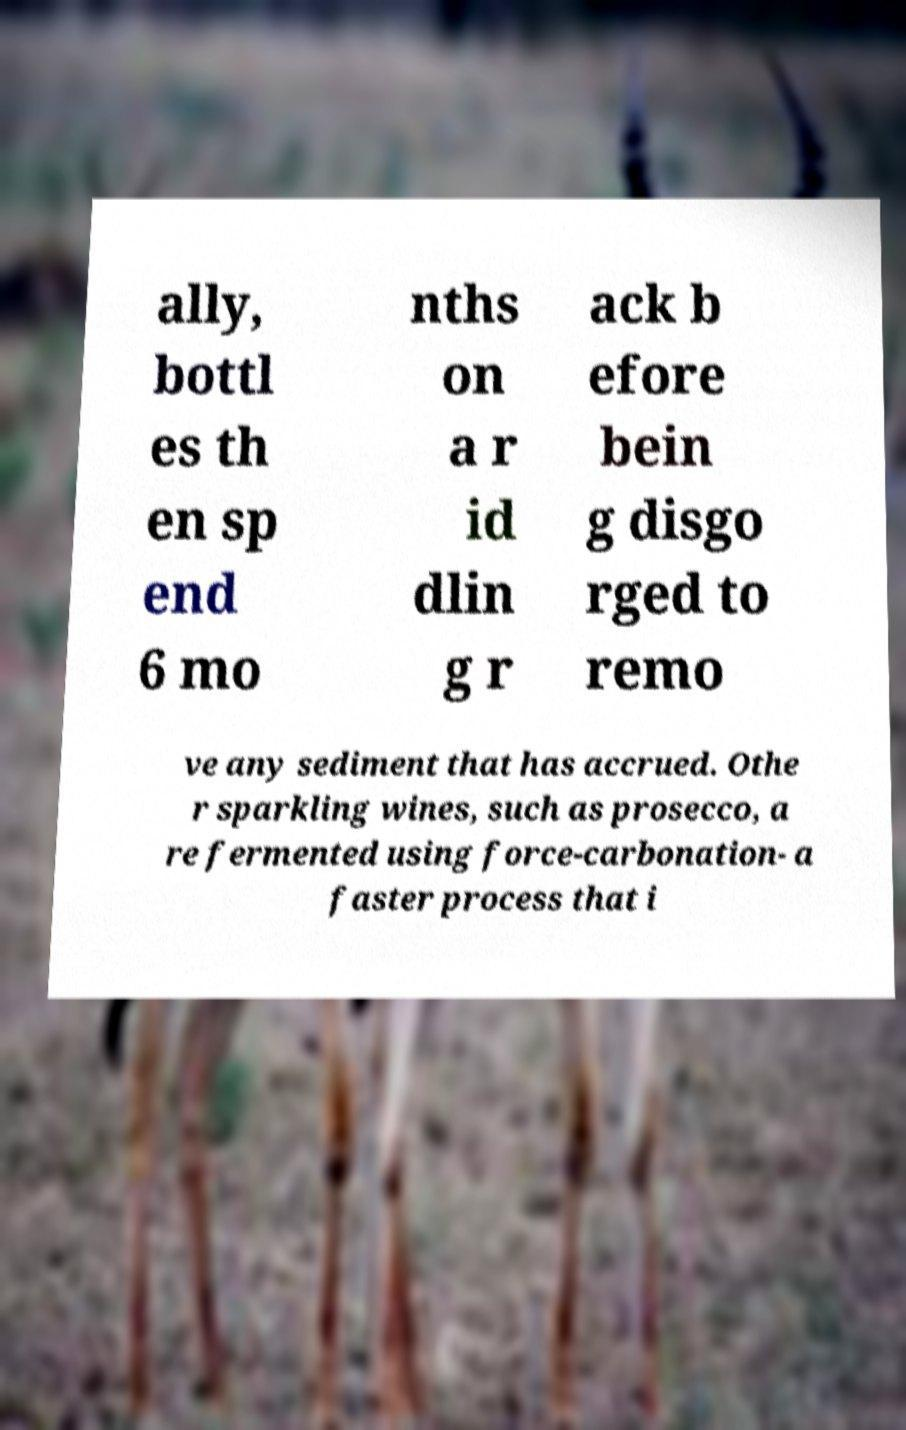Could you assist in decoding the text presented in this image and type it out clearly? ally, bottl es th en sp end 6 mo nths on a r id dlin g r ack b efore bein g disgo rged to remo ve any sediment that has accrued. Othe r sparkling wines, such as prosecco, a re fermented using force-carbonation- a faster process that i 